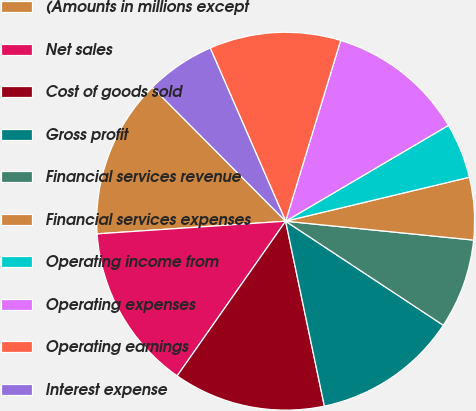<chart> <loc_0><loc_0><loc_500><loc_500><pie_chart><fcel>(Amounts in millions except<fcel>Net sales<fcel>Cost of goods sold<fcel>Gross profit<fcel>Financial services revenue<fcel>Financial services expenses<fcel>Operating income from<fcel>Operating expenses<fcel>Operating earnings<fcel>Interest expense<nl><fcel>13.61%<fcel>14.2%<fcel>13.02%<fcel>12.43%<fcel>7.69%<fcel>5.33%<fcel>4.73%<fcel>11.83%<fcel>11.24%<fcel>5.92%<nl></chart> 